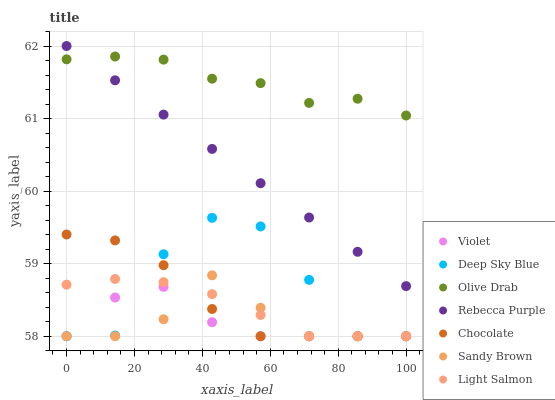Does Violet have the minimum area under the curve?
Answer yes or no. Yes. Does Olive Drab have the maximum area under the curve?
Answer yes or no. Yes. Does Chocolate have the minimum area under the curve?
Answer yes or no. No. Does Chocolate have the maximum area under the curve?
Answer yes or no. No. Is Rebecca Purple the smoothest?
Answer yes or no. Yes. Is Deep Sky Blue the roughest?
Answer yes or no. Yes. Is Chocolate the smoothest?
Answer yes or no. No. Is Chocolate the roughest?
Answer yes or no. No. Does Light Salmon have the lowest value?
Answer yes or no. Yes. Does Rebecca Purple have the lowest value?
Answer yes or no. No. Does Rebecca Purple have the highest value?
Answer yes or no. Yes. Does Chocolate have the highest value?
Answer yes or no. No. Is Light Salmon less than Olive Drab?
Answer yes or no. Yes. Is Rebecca Purple greater than Chocolate?
Answer yes or no. Yes. Does Olive Drab intersect Rebecca Purple?
Answer yes or no. Yes. Is Olive Drab less than Rebecca Purple?
Answer yes or no. No. Is Olive Drab greater than Rebecca Purple?
Answer yes or no. No. Does Light Salmon intersect Olive Drab?
Answer yes or no. No. 